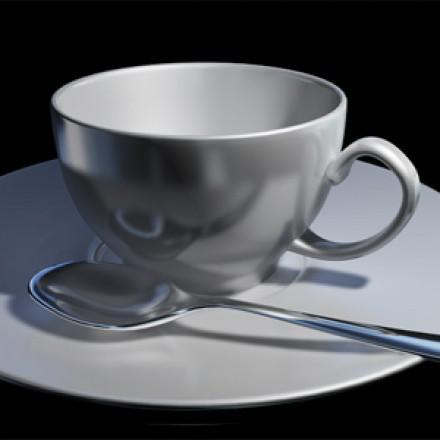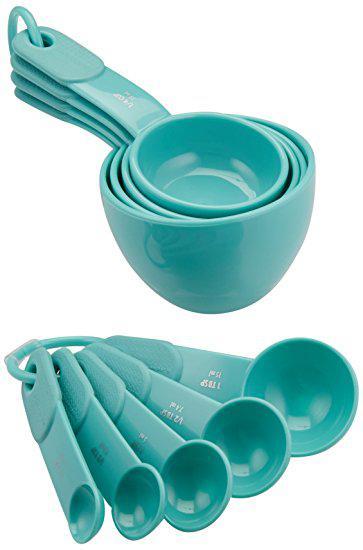The first image is the image on the left, the second image is the image on the right. Examine the images to the left and right. Is the description "Measuring spoons and cups appear in at least one image." accurate? Answer yes or no. Yes. 